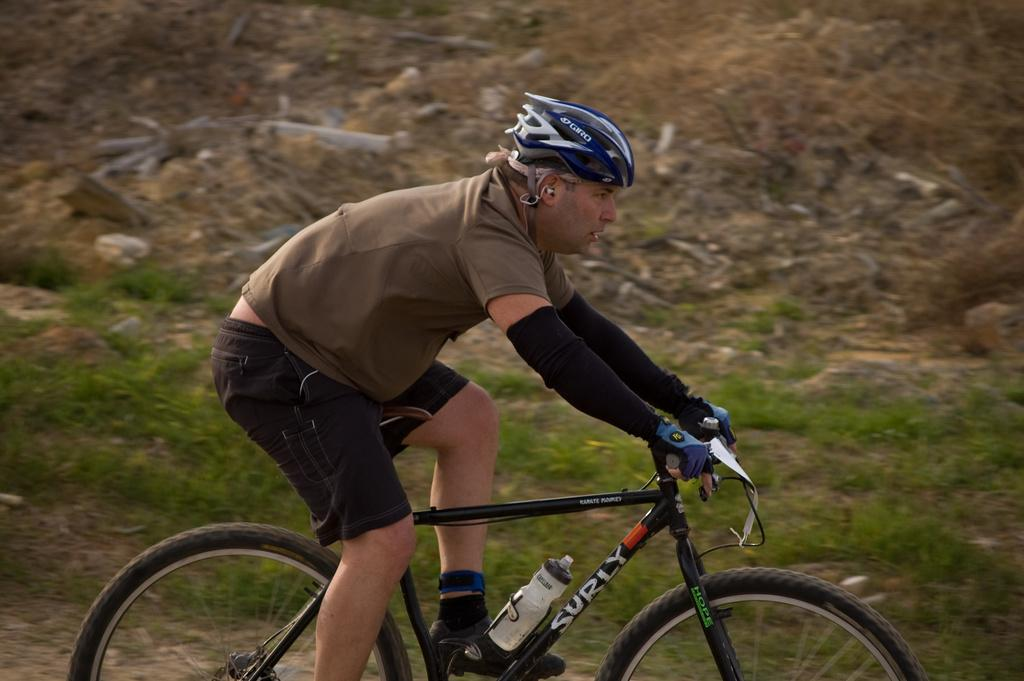What is the main subject of the image? There is a person in the image. What is the person wearing on their feet? The person is wearing socks and shoes. What protective gear is the person wearing? The person is wearing a helmet and gloves. What activity is the person engaged in? The person is riding a bicycle. What type of terrain can be seen in the image? There is grass visible in the image. What type of stove can be seen in the image? There is no stove present in the image. What subject is the person teaching in the image? There is no indication of teaching or any subject being taught in the image. 